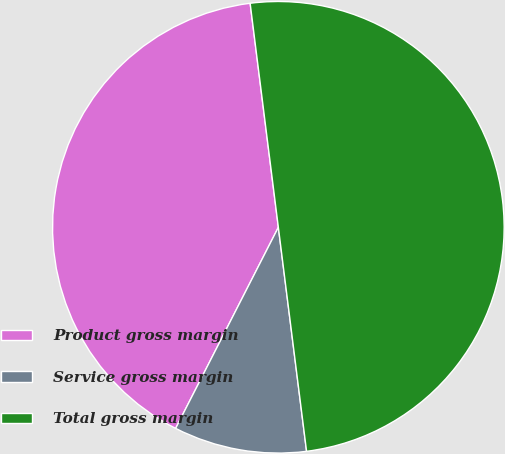Convert chart to OTSL. <chart><loc_0><loc_0><loc_500><loc_500><pie_chart><fcel>Product gross margin<fcel>Service gross margin<fcel>Total gross margin<nl><fcel>40.49%<fcel>9.51%<fcel>50.0%<nl></chart> 